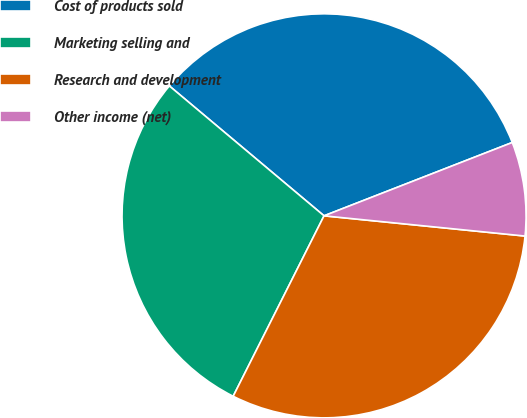Convert chart. <chart><loc_0><loc_0><loc_500><loc_500><pie_chart><fcel>Cost of products sold<fcel>Marketing selling and<fcel>Research and development<fcel>Other income (net)<nl><fcel>32.97%<fcel>28.69%<fcel>30.83%<fcel>7.51%<nl></chart> 